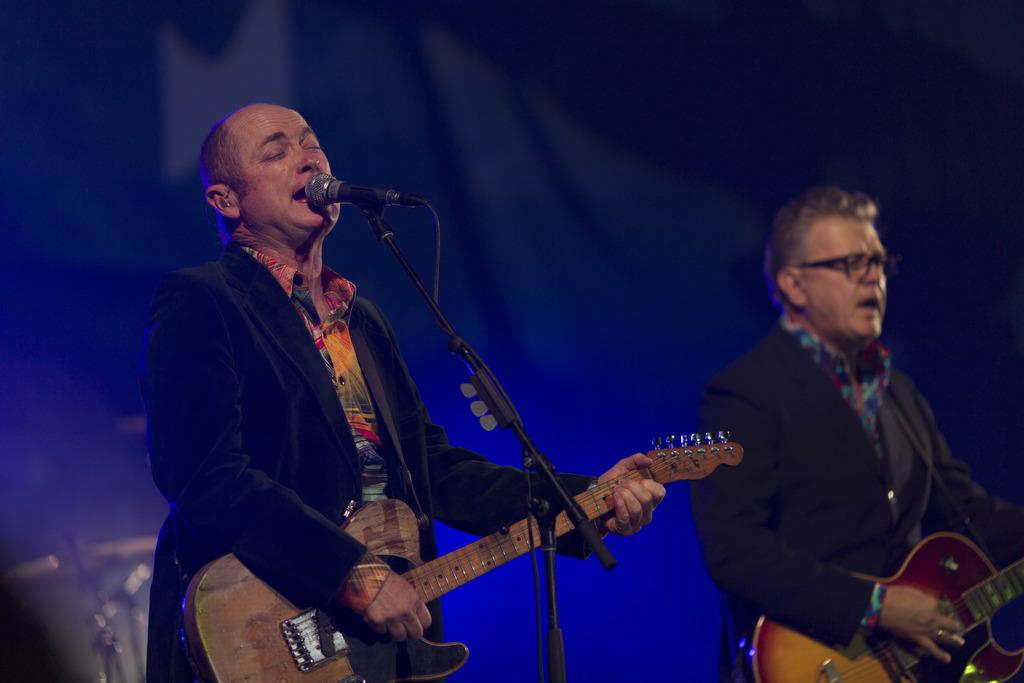How many people are in the image? There are two people in the image. What are the two people holding? The two people are holding guitars. What other object can be seen in the image? There is a microphone (mic) in the image. Can you see a snake slithering across the field in the image? There is no snake or field present in the image; it features two people holding guitars and a microphone. 